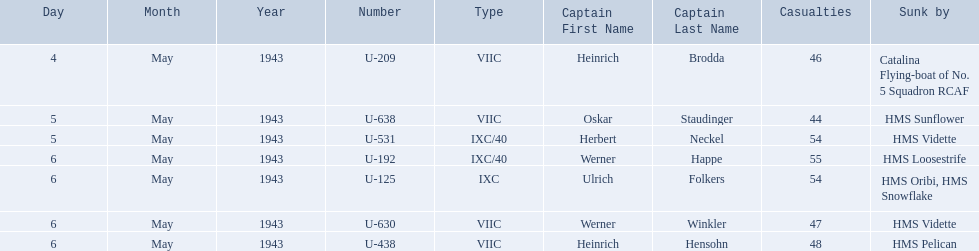Who are all of the captains? Heinrich Brodda, Oskar Staudinger, Herbert Neckel, Werner Happe, Ulrich Folkers, Werner Winkler, Heinrich Hensohn. What sunk each of the captains? Catalina Flying-boat of No. 5 Squadron RCAF, HMS Sunflower, HMS Vidette, HMS Loosestrife, HMS Oribi, HMS Snowflake, HMS Vidette, HMS Pelican. Which was sunk by the hms pelican? Heinrich Hensohn. 